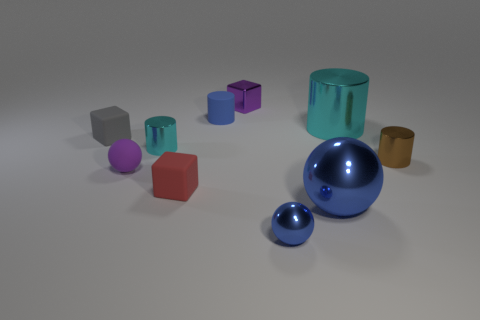The blue object that is the same shape as the tiny brown object is what size?
Offer a terse response. Small. What is the size of the shiny cylinder that is both on the left side of the brown metallic cylinder and right of the big blue sphere?
Provide a succinct answer. Large. There is a matte thing that is the same color as the shiny cube; what shape is it?
Keep it short and to the point. Sphere. The rubber sphere has what color?
Keep it short and to the point. Purple. How big is the blue rubber object right of the small gray object?
Offer a very short reply. Small. How many small blue metallic spheres are left of the shiny ball that is left of the large metallic thing in front of the small brown metal cylinder?
Provide a short and direct response. 0. The metal thing in front of the large thing that is in front of the tiny red rubber cube is what color?
Your response must be concise. Blue. Is there a thing of the same size as the gray matte block?
Offer a very short reply. Yes. There is a big blue thing that is in front of the small matte block in front of the cyan thing that is to the left of the large cyan cylinder; what is its material?
Your answer should be compact. Metal. There is a tiny cylinder that is behind the small cyan metal object; how many big things are left of it?
Provide a short and direct response. 0. 